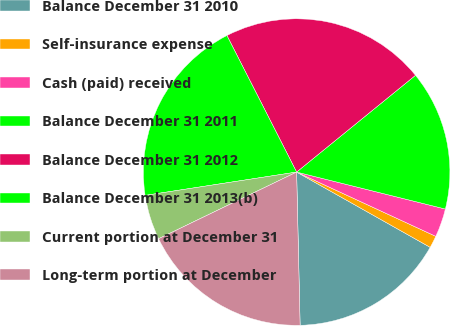<chart> <loc_0><loc_0><loc_500><loc_500><pie_chart><fcel>Balance December 31 2010<fcel>Self-insurance expense<fcel>Cash (paid) received<fcel>Balance December 31 2011<fcel>Balance December 31 2012<fcel>Balance December 31 2013(b)<fcel>Current portion at December 31<fcel>Long-term portion at December<nl><fcel>16.47%<fcel>1.28%<fcel>3.01%<fcel>14.75%<fcel>21.64%<fcel>19.92%<fcel>4.73%<fcel>18.2%<nl></chart> 